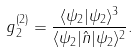Convert formula to latex. <formula><loc_0><loc_0><loc_500><loc_500>g ^ { ( 2 ) } _ { 2 } = \frac { \langle \psi _ { 2 } | \psi _ { 2 } \rangle ^ { 3 } } { \langle \psi _ { 2 } | \hat { n } | \psi _ { 2 } \rangle ^ { 2 } } .</formula> 